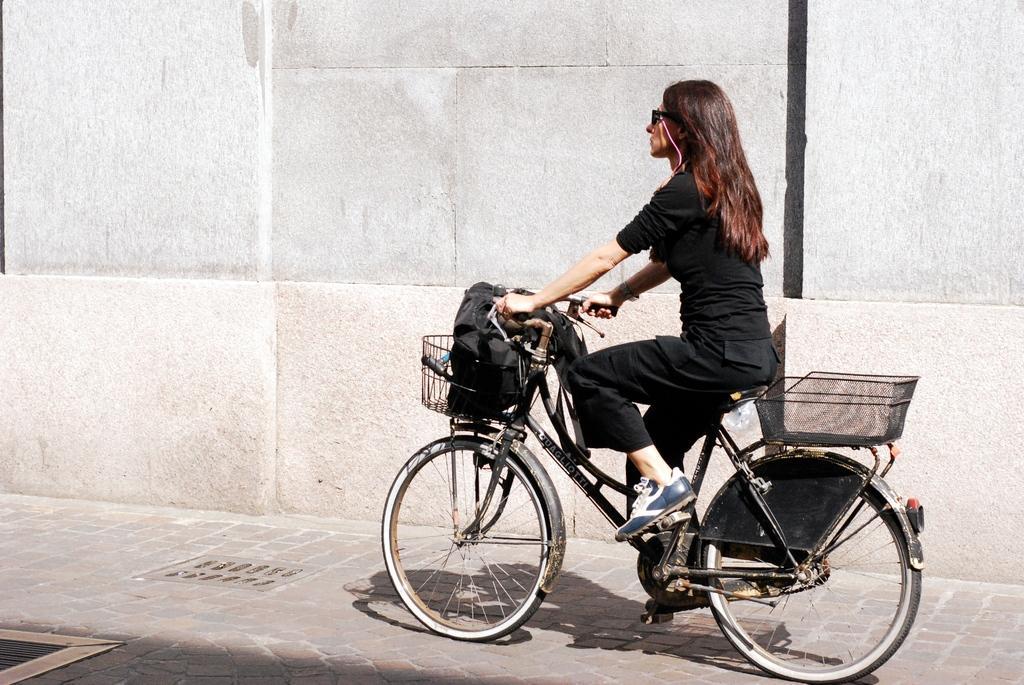Can you describe this image briefly? In this picture we can see a woman riding a bicycle, bicycle contains baskets in the front and back, in the background we can see a wall. 